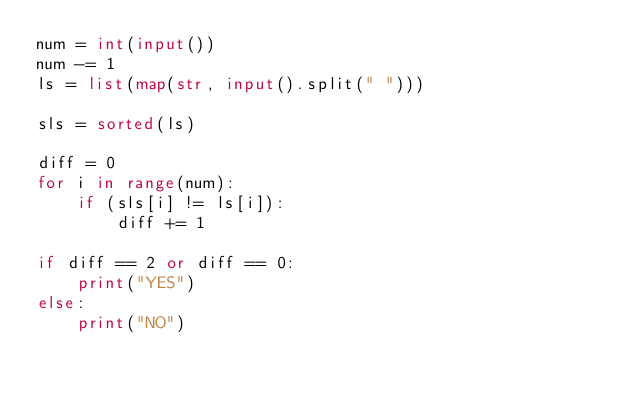Convert code to text. <code><loc_0><loc_0><loc_500><loc_500><_Python_>num = int(input())
num -= 1
ls = list(map(str, input().split(" ")))

sls = sorted(ls)

diff = 0
for i in range(num):
    if (sls[i] != ls[i]):
        diff += 1

if diff == 2 or diff == 0:
    print("YES")
else:
    print("NO")</code> 